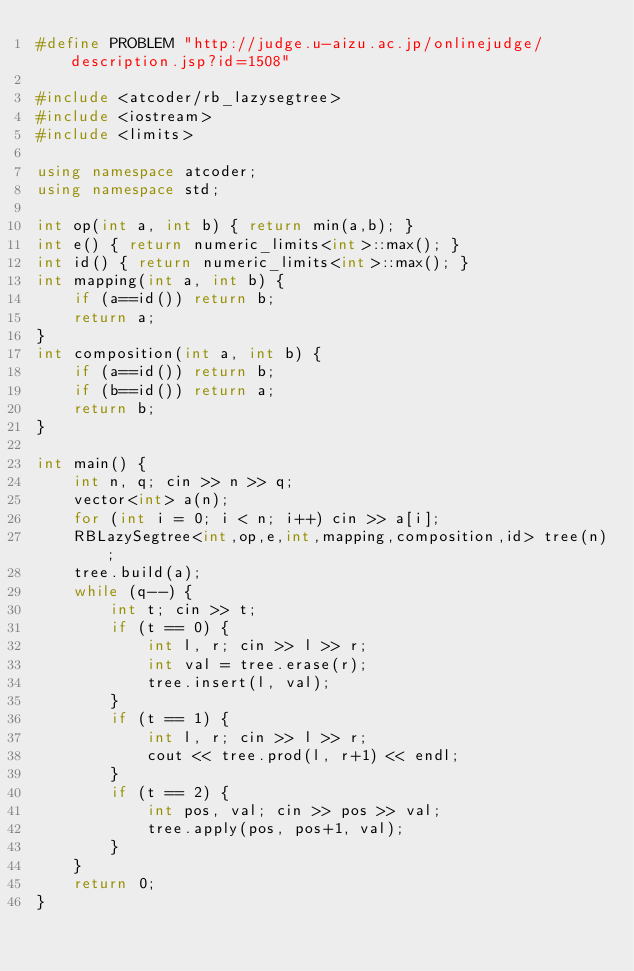<code> <loc_0><loc_0><loc_500><loc_500><_C++_>#define PROBLEM "http://judge.u-aizu.ac.jp/onlinejudge/description.jsp?id=1508"

#include <atcoder/rb_lazysegtree>
#include <iostream>
#include <limits>

using namespace atcoder;
using namespace std;

int op(int a, int b) { return min(a,b); }
int e() { return numeric_limits<int>::max(); }
int id() { return numeric_limits<int>::max(); }
int mapping(int a, int b) {
    if (a==id()) return b;
    return a;
}
int composition(int a, int b) {
    if (a==id()) return b;
    if (b==id()) return a;
    return b;
}

int main() {
    int n, q; cin >> n >> q;
    vector<int> a(n);
    for (int i = 0; i < n; i++) cin >> a[i];
    RBLazySegtree<int,op,e,int,mapping,composition,id> tree(n);
    tree.build(a);
    while (q--) {
        int t; cin >> t;
        if (t == 0) {
            int l, r; cin >> l >> r;
            int val = tree.erase(r);
            tree.insert(l, val);
        }
        if (t == 1) {
            int l, r; cin >> l >> r;
            cout << tree.prod(l, r+1) << endl;
        }
        if (t == 2) {
            int pos, val; cin >> pos >> val;
            tree.apply(pos, pos+1, val);
        }
    }
    return 0;
}
</code> 